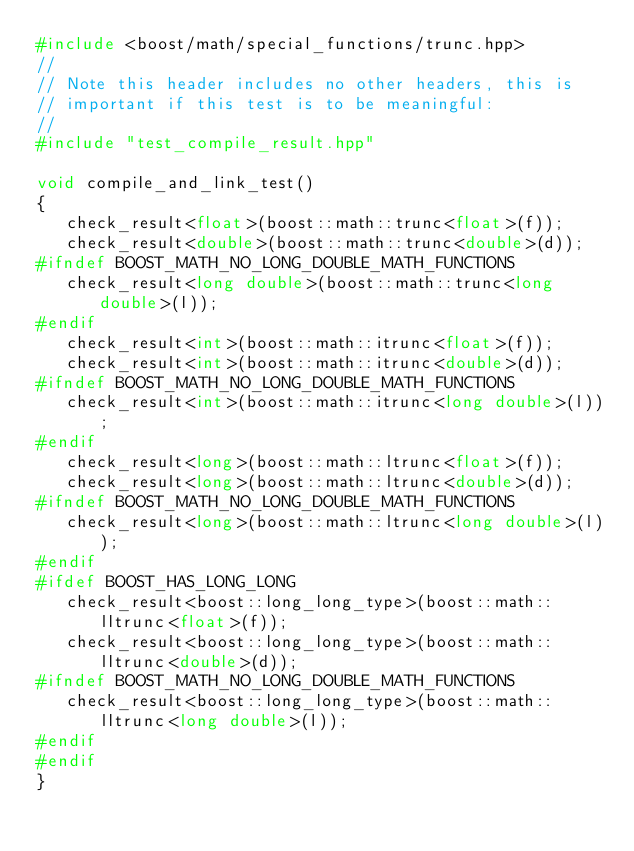Convert code to text. <code><loc_0><loc_0><loc_500><loc_500><_C++_>#include <boost/math/special_functions/trunc.hpp>
//
// Note this header includes no other headers, this is
// important if this test is to be meaningful:
//
#include "test_compile_result.hpp"

void compile_and_link_test()
{
   check_result<float>(boost::math::trunc<float>(f));
   check_result<double>(boost::math::trunc<double>(d));
#ifndef BOOST_MATH_NO_LONG_DOUBLE_MATH_FUNCTIONS
   check_result<long double>(boost::math::trunc<long double>(l));
#endif
   check_result<int>(boost::math::itrunc<float>(f));
   check_result<int>(boost::math::itrunc<double>(d));
#ifndef BOOST_MATH_NO_LONG_DOUBLE_MATH_FUNCTIONS
   check_result<int>(boost::math::itrunc<long double>(l));
#endif
   check_result<long>(boost::math::ltrunc<float>(f));
   check_result<long>(boost::math::ltrunc<double>(d));
#ifndef BOOST_MATH_NO_LONG_DOUBLE_MATH_FUNCTIONS
   check_result<long>(boost::math::ltrunc<long double>(l));
#endif
#ifdef BOOST_HAS_LONG_LONG
   check_result<boost::long_long_type>(boost::math::lltrunc<float>(f));
   check_result<boost::long_long_type>(boost::math::lltrunc<double>(d));
#ifndef BOOST_MATH_NO_LONG_DOUBLE_MATH_FUNCTIONS
   check_result<boost::long_long_type>(boost::math::lltrunc<long double>(l));
#endif
#endif
}
</code> 